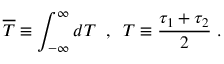Convert formula to latex. <formula><loc_0><loc_0><loc_500><loc_500>\overline { T } \equiv \int _ { - \infty } ^ { \infty } d T \, , \, T \equiv \frac { \tau _ { 1 } + \tau _ { 2 } } 2 \, .</formula> 